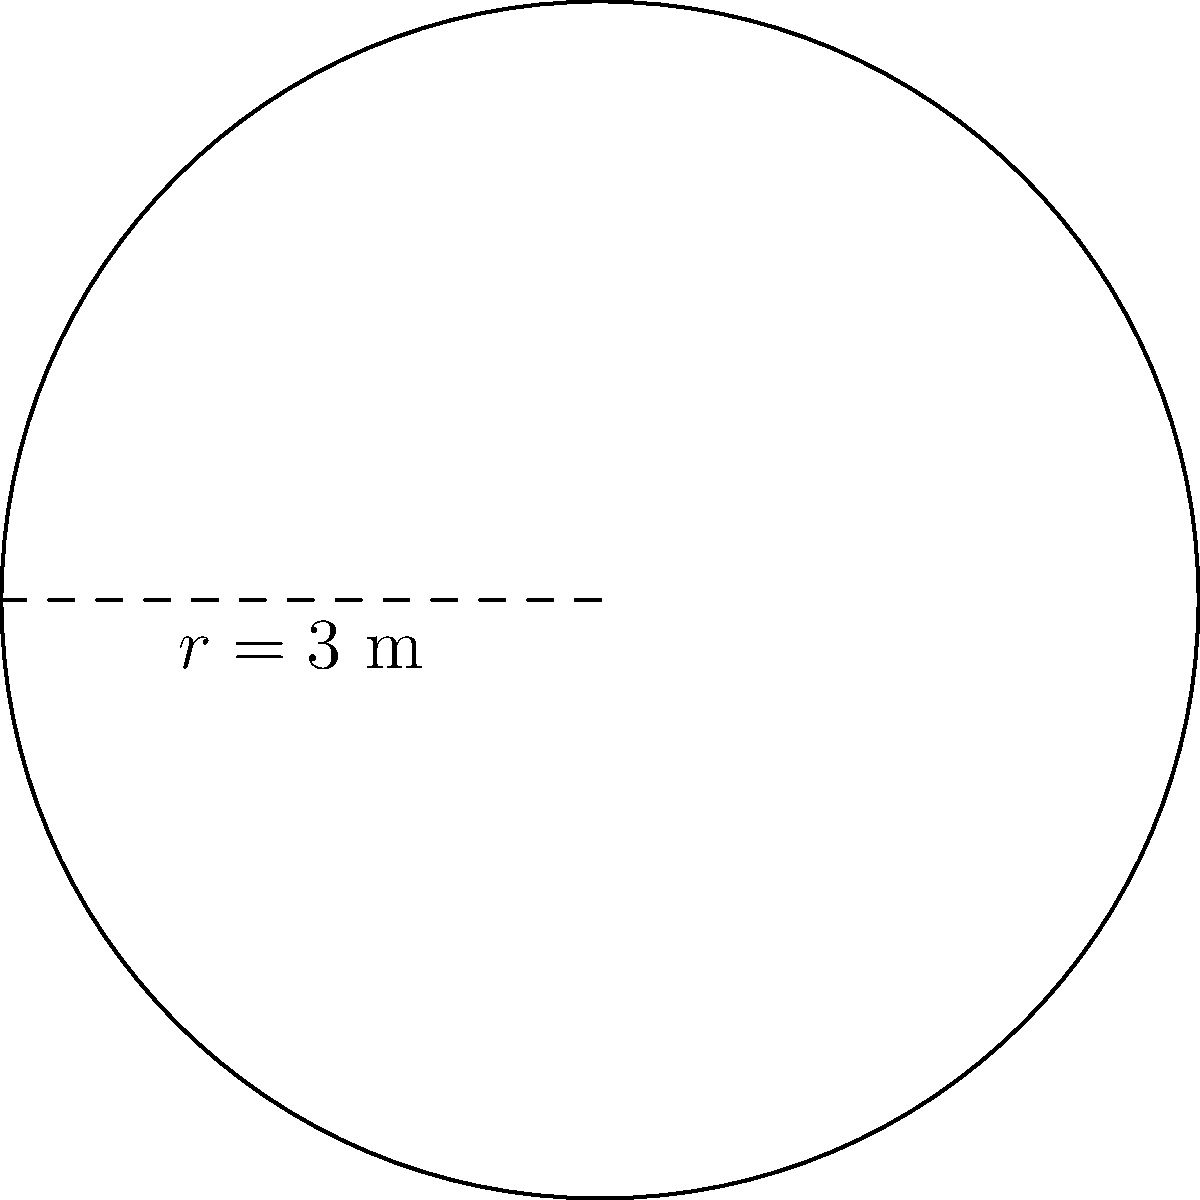As a business mentor, you're advising on the setup for a new conference room. The centerpiece is a circular table with a radius of 3 meters. To ensure proper spacing, you need to calculate the table's perimeter. What is the perimeter of the conference table? Let's approach this step-by-step:

1) The formula for the perimeter (circumference) of a circle is:
   $$P = 2\pi r$$
   where $P$ is the perimeter, $\pi$ is pi, and $r$ is the radius.

2) We're given that the radius is 3 meters.

3) Let's substitute these values into our formula:
   $$P = 2\pi (3)$$

4) Simplify:
   $$P = 6\pi$$

5) If we need a decimal approximation, we can use $\pi \approx 3.14159$:
   $$P \approx 6 * 3.14159 \approx 18.85 \text{ meters}$$

6) However, it's often best to leave the answer in terms of $\pi$ for precision.
Answer: $6\pi$ meters 